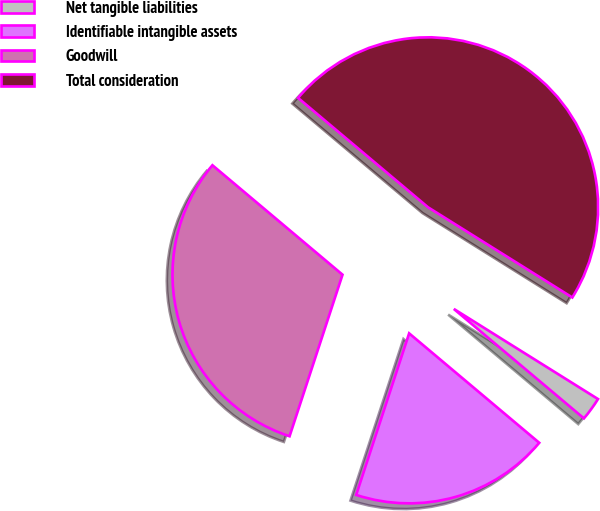Convert chart. <chart><loc_0><loc_0><loc_500><loc_500><pie_chart><fcel>Net tangible liabilities<fcel>Identifiable intangible assets<fcel>Goodwill<fcel>Total consideration<nl><fcel>2.24%<fcel>18.91%<fcel>31.09%<fcel>47.76%<nl></chart> 